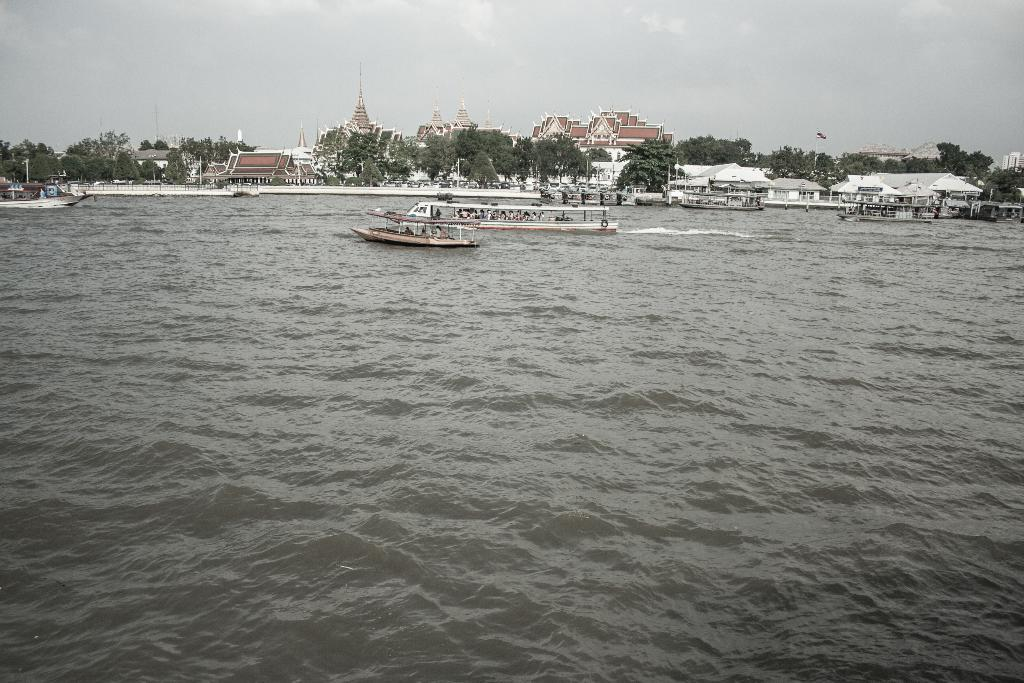What type of structures can be seen in the image? There are houses in the image. What natural feature is present in the image? There are ships on a river in the image. What type of vegetation is visible in the image? There are trees visible in the image. What part of the natural environment is visible in the image? The sky is visible in the image. What is the tendency of the river to cause anger in the image? There is no indication of anger or any emotional response in the image; it simply shows houses, ships on a river, trees, and the sky. Is there a bridge visible in the image? No, there is no bridge present in the image. 